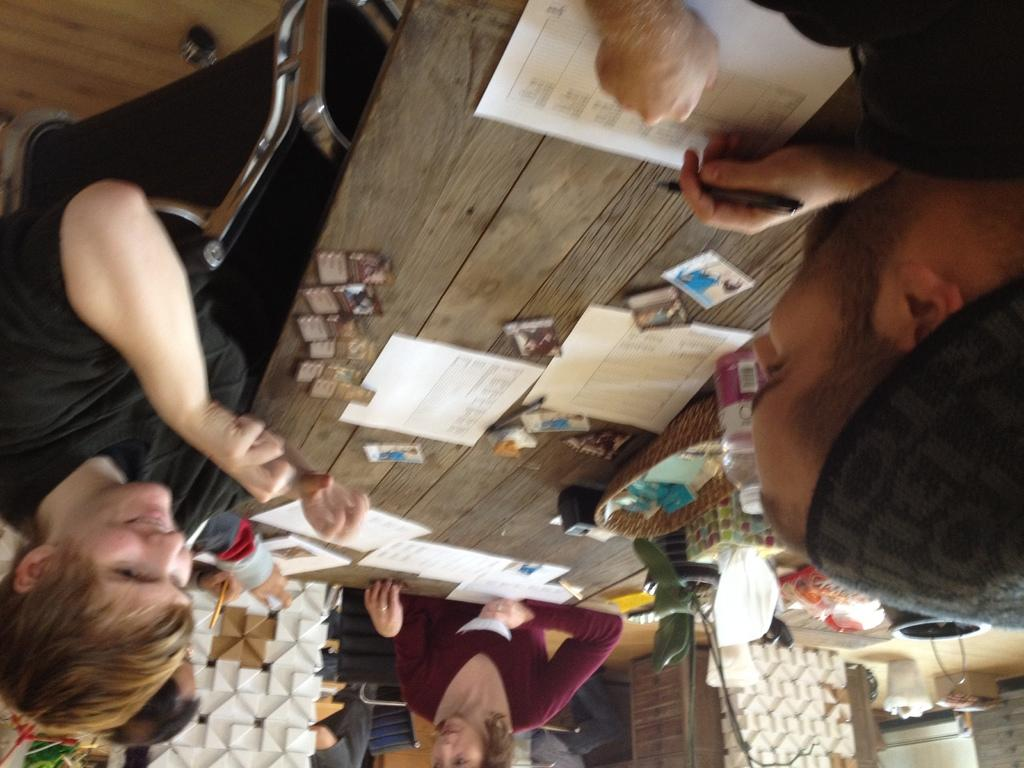What are the people in the image doing? The persons in the image are sitting on chairs. What can be seen on the table in the image? There are objects on the table in the image. What is located at the bottom of the image? There is a white object, a houseplant, a dustbin, and a wooden table at the bottom of the image. What type of lettuce is being used as a veil in the image? There is no lettuce or veil present in the image. What is the income of the persons sitting in the image? The income of the persons sitting in the image cannot be determined from the image. 